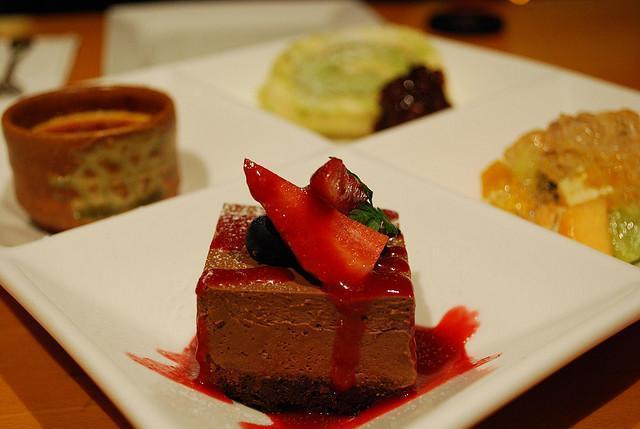How many cakes are in the photo?
Give a very brief answer. 2. 